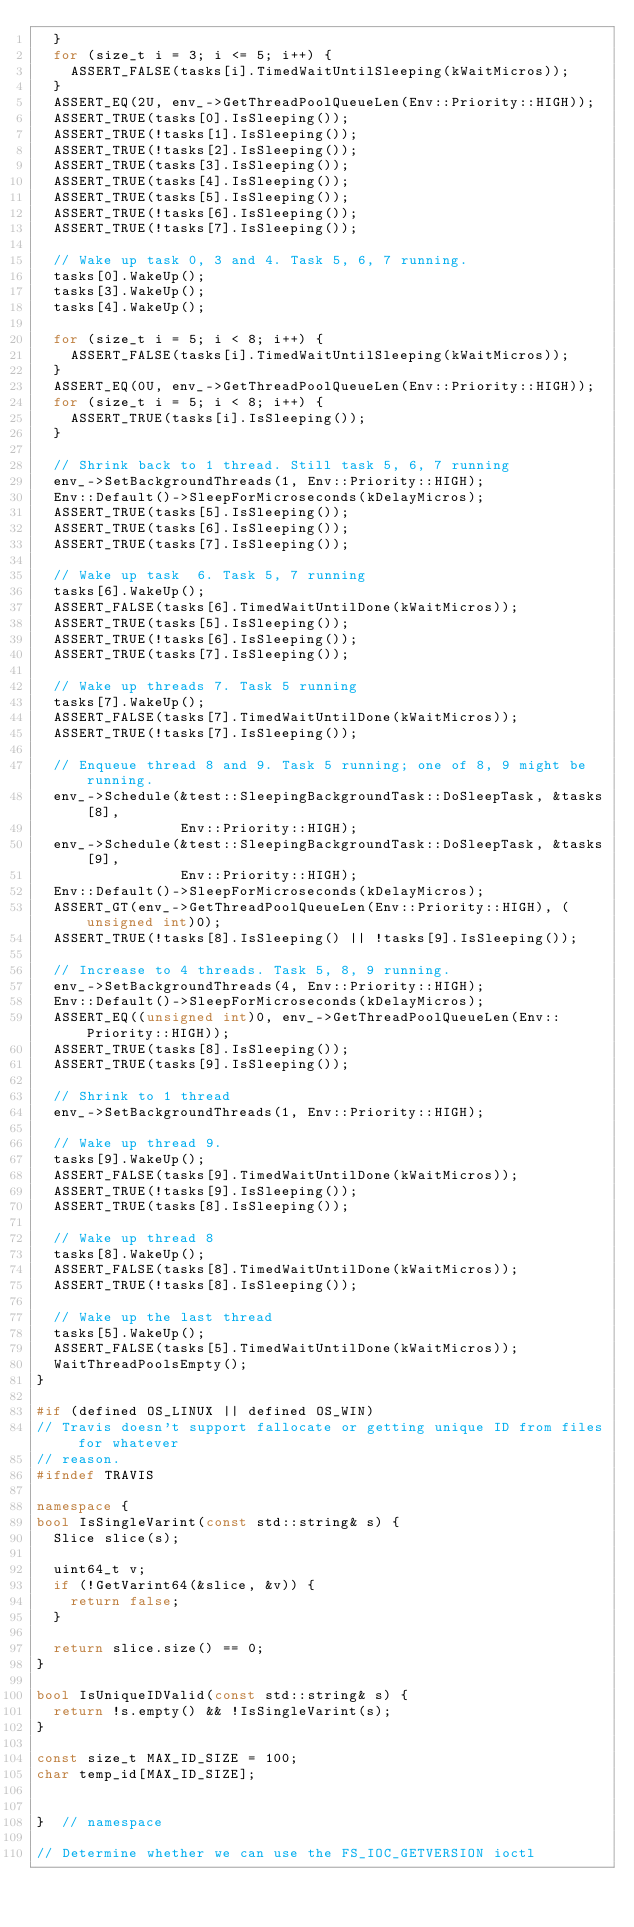Convert code to text. <code><loc_0><loc_0><loc_500><loc_500><_C++_>  }
  for (size_t i = 3; i <= 5; i++) {
    ASSERT_FALSE(tasks[i].TimedWaitUntilSleeping(kWaitMicros));
  }
  ASSERT_EQ(2U, env_->GetThreadPoolQueueLen(Env::Priority::HIGH));
  ASSERT_TRUE(tasks[0].IsSleeping());
  ASSERT_TRUE(!tasks[1].IsSleeping());
  ASSERT_TRUE(!tasks[2].IsSleeping());
  ASSERT_TRUE(tasks[3].IsSleeping());
  ASSERT_TRUE(tasks[4].IsSleeping());
  ASSERT_TRUE(tasks[5].IsSleeping());
  ASSERT_TRUE(!tasks[6].IsSleeping());
  ASSERT_TRUE(!tasks[7].IsSleeping());

  // Wake up task 0, 3 and 4. Task 5, 6, 7 running.
  tasks[0].WakeUp();
  tasks[3].WakeUp();
  tasks[4].WakeUp();

  for (size_t i = 5; i < 8; i++) {
    ASSERT_FALSE(tasks[i].TimedWaitUntilSleeping(kWaitMicros));
  }
  ASSERT_EQ(0U, env_->GetThreadPoolQueueLen(Env::Priority::HIGH));
  for (size_t i = 5; i < 8; i++) {
    ASSERT_TRUE(tasks[i].IsSleeping());
  }

  // Shrink back to 1 thread. Still task 5, 6, 7 running
  env_->SetBackgroundThreads(1, Env::Priority::HIGH);
  Env::Default()->SleepForMicroseconds(kDelayMicros);
  ASSERT_TRUE(tasks[5].IsSleeping());
  ASSERT_TRUE(tasks[6].IsSleeping());
  ASSERT_TRUE(tasks[7].IsSleeping());

  // Wake up task  6. Task 5, 7 running
  tasks[6].WakeUp();
  ASSERT_FALSE(tasks[6].TimedWaitUntilDone(kWaitMicros));
  ASSERT_TRUE(tasks[5].IsSleeping());
  ASSERT_TRUE(!tasks[6].IsSleeping());
  ASSERT_TRUE(tasks[7].IsSleeping());

  // Wake up threads 7. Task 5 running
  tasks[7].WakeUp();
  ASSERT_FALSE(tasks[7].TimedWaitUntilDone(kWaitMicros));
  ASSERT_TRUE(!tasks[7].IsSleeping());

  // Enqueue thread 8 and 9. Task 5 running; one of 8, 9 might be running.
  env_->Schedule(&test::SleepingBackgroundTask::DoSleepTask, &tasks[8],
                 Env::Priority::HIGH);
  env_->Schedule(&test::SleepingBackgroundTask::DoSleepTask, &tasks[9],
                 Env::Priority::HIGH);
  Env::Default()->SleepForMicroseconds(kDelayMicros);
  ASSERT_GT(env_->GetThreadPoolQueueLen(Env::Priority::HIGH), (unsigned int)0);
  ASSERT_TRUE(!tasks[8].IsSleeping() || !tasks[9].IsSleeping());

  // Increase to 4 threads. Task 5, 8, 9 running.
  env_->SetBackgroundThreads(4, Env::Priority::HIGH);
  Env::Default()->SleepForMicroseconds(kDelayMicros);
  ASSERT_EQ((unsigned int)0, env_->GetThreadPoolQueueLen(Env::Priority::HIGH));
  ASSERT_TRUE(tasks[8].IsSleeping());
  ASSERT_TRUE(tasks[9].IsSleeping());

  // Shrink to 1 thread
  env_->SetBackgroundThreads(1, Env::Priority::HIGH);

  // Wake up thread 9.
  tasks[9].WakeUp();
  ASSERT_FALSE(tasks[9].TimedWaitUntilDone(kWaitMicros));
  ASSERT_TRUE(!tasks[9].IsSleeping());
  ASSERT_TRUE(tasks[8].IsSleeping());

  // Wake up thread 8
  tasks[8].WakeUp();
  ASSERT_FALSE(tasks[8].TimedWaitUntilDone(kWaitMicros));
  ASSERT_TRUE(!tasks[8].IsSleeping());

  // Wake up the last thread
  tasks[5].WakeUp();
  ASSERT_FALSE(tasks[5].TimedWaitUntilDone(kWaitMicros));
  WaitThreadPoolsEmpty();
}

#if (defined OS_LINUX || defined OS_WIN)
// Travis doesn't support fallocate or getting unique ID from files for whatever
// reason.
#ifndef TRAVIS

namespace {
bool IsSingleVarint(const std::string& s) {
  Slice slice(s);

  uint64_t v;
  if (!GetVarint64(&slice, &v)) {
    return false;
  }

  return slice.size() == 0;
}

bool IsUniqueIDValid(const std::string& s) {
  return !s.empty() && !IsSingleVarint(s);
}

const size_t MAX_ID_SIZE = 100;
char temp_id[MAX_ID_SIZE];


}  // namespace

// Determine whether we can use the FS_IOC_GETVERSION ioctl</code> 